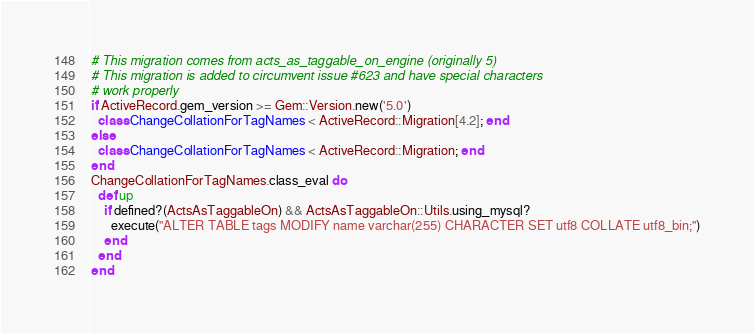<code> <loc_0><loc_0><loc_500><loc_500><_Ruby_># This migration comes from acts_as_taggable_on_engine (originally 5)
# This migration is added to circumvent issue #623 and have special characters
# work properly
if ActiveRecord.gem_version >= Gem::Version.new('5.0')
  class ChangeCollationForTagNames < ActiveRecord::Migration[4.2]; end
else
  class ChangeCollationForTagNames < ActiveRecord::Migration; end
end
ChangeCollationForTagNames.class_eval do
  def up
    if defined?(ActsAsTaggableOn) && ActsAsTaggableOn::Utils.using_mysql?
      execute("ALTER TABLE tags MODIFY name varchar(255) CHARACTER SET utf8 COLLATE utf8_bin;")
    end
  end
end
</code> 